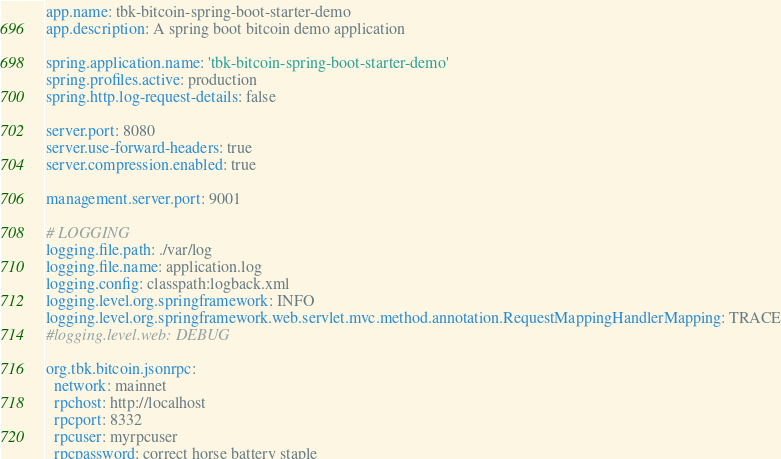<code> <loc_0><loc_0><loc_500><loc_500><_YAML_>app.name: tbk-bitcoin-spring-boot-starter-demo
app.description: A spring boot bitcoin demo application

spring.application.name: 'tbk-bitcoin-spring-boot-starter-demo'
spring.profiles.active: production
spring.http.log-request-details: false

server.port: 8080
server.use-forward-headers: true
server.compression.enabled: true

management.server.port: 9001

# LOGGING
logging.file.path: ./var/log
logging.file.name: application.log
logging.config: classpath:logback.xml
logging.level.org.springframework: INFO
logging.level.org.springframework.web.servlet.mvc.method.annotation.RequestMappingHandlerMapping: TRACE
#logging.level.web: DEBUG

org.tbk.bitcoin.jsonrpc:
  network: mainnet
  rpchost: http://localhost
  rpcport: 8332
  rpcuser: myrpcuser
  rpcpassword: correct horse battery staple
</code> 